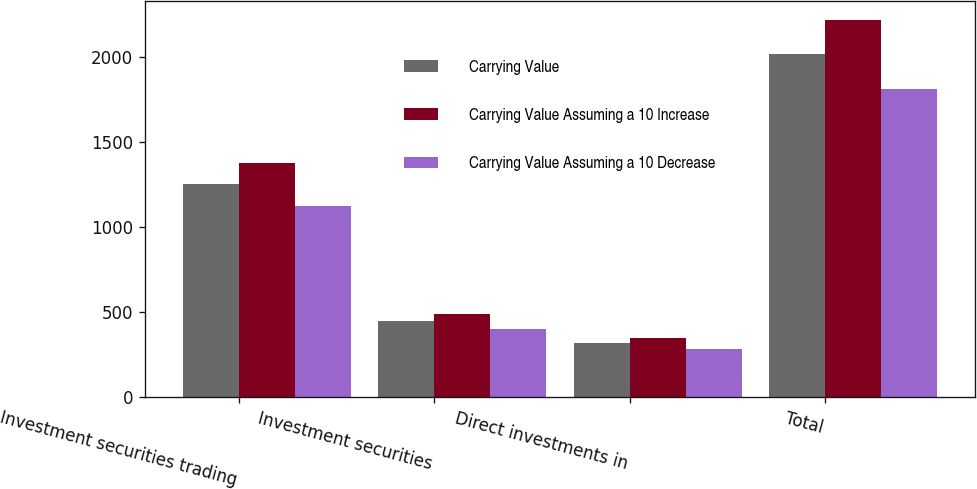Convert chart. <chart><loc_0><loc_0><loc_500><loc_500><stacked_bar_chart><ecel><fcel>Investment securities trading<fcel>Investment securities<fcel>Direct investments in<fcel>Total<nl><fcel>Carrying Value<fcel>1251.2<fcel>446.4<fcel>316.3<fcel>2013.9<nl><fcel>Carrying Value Assuming a 10 Increase<fcel>1376.3<fcel>491<fcel>347.9<fcel>2215.2<nl><fcel>Carrying Value Assuming a 10 Decrease<fcel>1126.1<fcel>401.8<fcel>284.7<fcel>1812.6<nl></chart> 